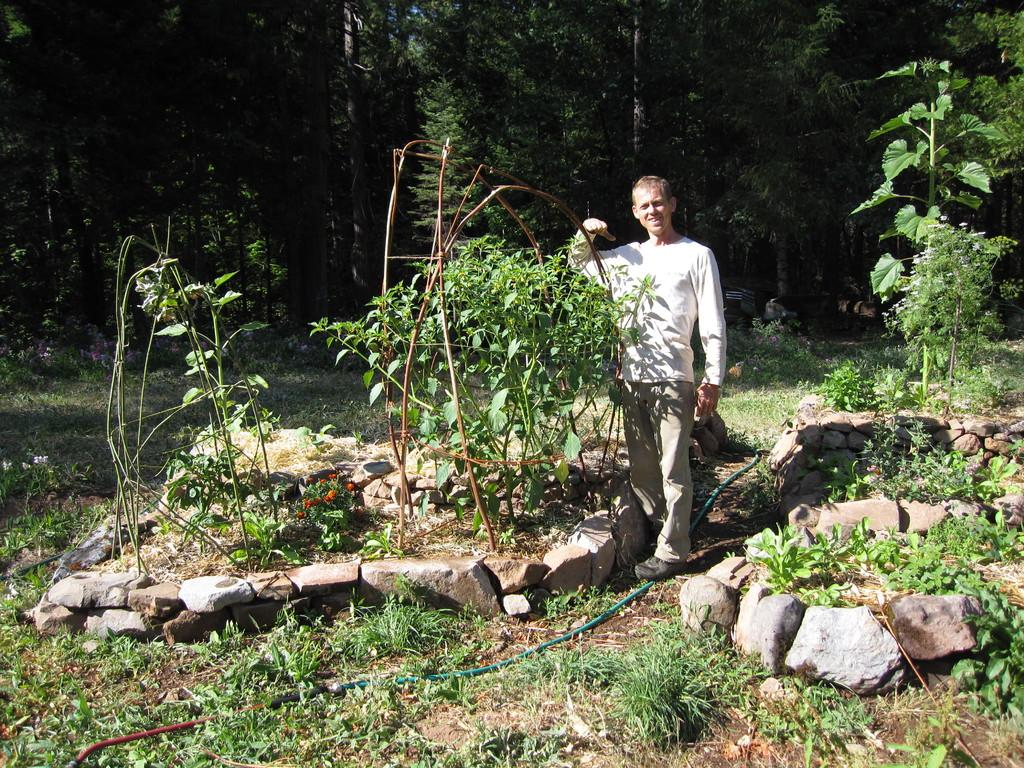What is the main subject of the image? There is a person standing in the image. What can be seen in the background of the image? There are trees visible in the background. What type of terrain is depicted at the bottom of the image? There are stones at the bottom of the image. What type of vegetation is present in the image? There are plants and flowers in the image. What other objects can be seen in the image? There is a pipe in the image. What type of ground is visible in the image? Grass is visible in the image. What type of soil is present in the image? Mud is present in the image. What is the creator's mind like in the image? There is no reference to a creator or their mind in the image; it depicts a person standing in a natural environment. 